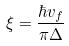<formula> <loc_0><loc_0><loc_500><loc_500>\xi = \frac { \hbar { v } _ { f } } { \pi \Delta }</formula> 